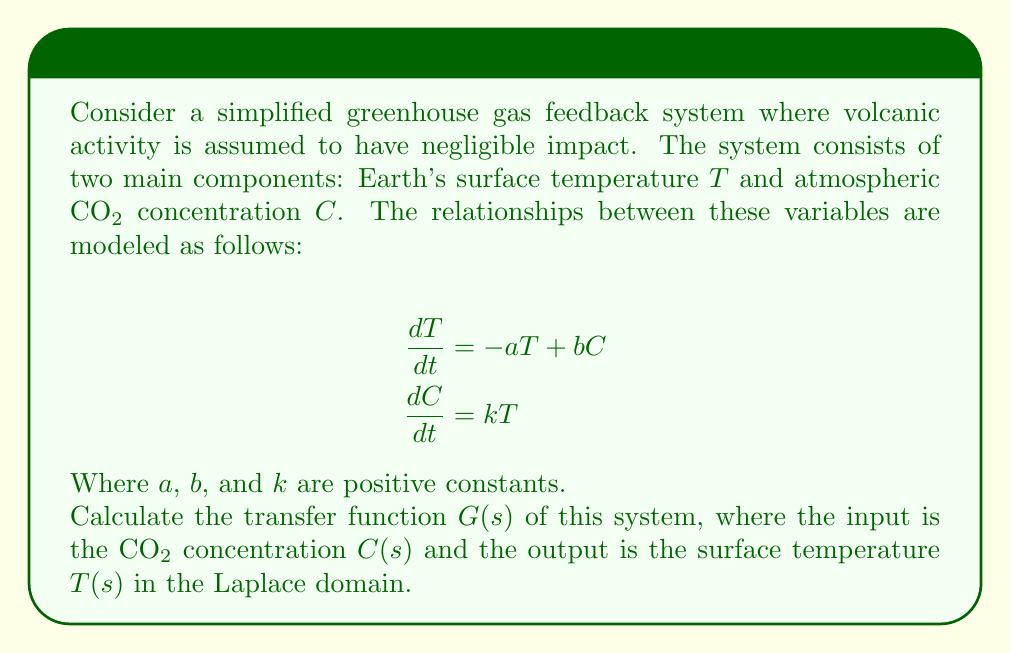Could you help me with this problem? To find the transfer function, we need to follow these steps:

1) First, let's take the Laplace transform of both equations:

   $$sT(s) - T(0) = -aT(s) + bC(s)$$
   $$sC(s) - C(0) = kT(s)$$

2) Assuming zero initial conditions (T(0) = C(0) = 0), we get:

   $$sT(s) = -aT(s) + bC(s)$$
   $$sC(s) = kT(s)$$

3) Rearrange the first equation:

   $$(s+a)T(s) = bC(s)$$

4) The transfer function is defined as the ratio of output to input in the Laplace domain:

   $$G(s) = \frac{T(s)}{C(s)}$$

5) From step 3, we can express this ratio:

   $$G(s) = \frac{T(s)}{C(s)} = \frac{b}{s+a}$$

6) This is our transfer function. However, we can further refine it by incorporating the relationship between T(s) and C(s) from the second equation:

   $$C(s) = \frac{k}{s}T(s)$$

7) Substituting this into our transfer function:

   $$G(s) = \frac{T(s)}{C(s)} = \frac{T(s)}{\frac{k}{s}T(s)} = \frac{s}{k}$$

8) Equating our two expressions for G(s):

   $$\frac{b}{s+a} = \frac{s}{k}$$

9) Cross-multiplying:

   $$bk = s^2 + as$$

10) Therefore, the final transfer function is:

    $$G(s) = \frac{b}{s+a} = \frac{s}{k} = \frac{bs}{s^2 + as}$$

This transfer function represents the relationship between CO2 concentration and surface temperature in this simplified greenhouse gas feedback system, without considering volcanic activity.
Answer: $$G(s) = \frac{bs}{s^2 + as}$$ 